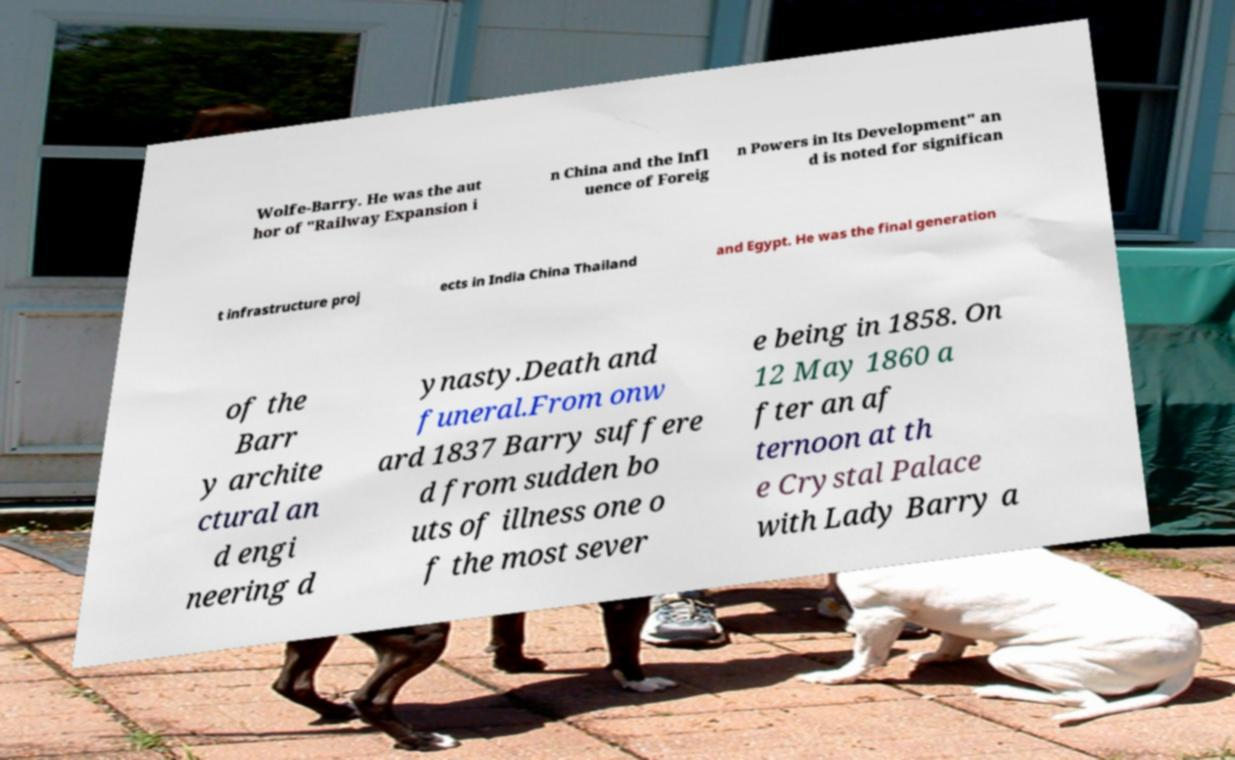I need the written content from this picture converted into text. Can you do that? Wolfe-Barry. He was the aut hor of "Railway Expansion i n China and the Infl uence of Foreig n Powers in Its Development" an d is noted for significan t infrastructure proj ects in India China Thailand and Egypt. He was the final generation of the Barr y archite ctural an d engi neering d ynasty.Death and funeral.From onw ard 1837 Barry suffere d from sudden bo uts of illness one o f the most sever e being in 1858. On 12 May 1860 a fter an af ternoon at th e Crystal Palace with Lady Barry a 